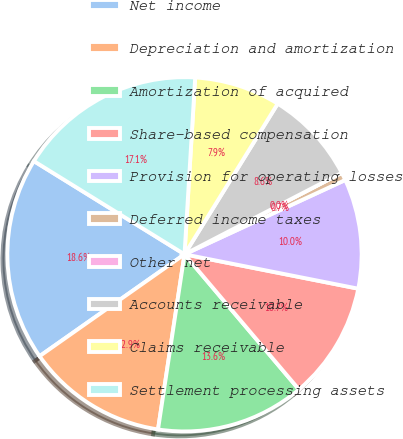<chart> <loc_0><loc_0><loc_500><loc_500><pie_chart><fcel>Net income<fcel>Depreciation and amortization<fcel>Amortization of acquired<fcel>Share-based compensation<fcel>Provision for operating losses<fcel>Deferred income taxes<fcel>Other net<fcel>Accounts receivable<fcel>Claims receivable<fcel>Settlement processing assets<nl><fcel>18.57%<fcel>12.86%<fcel>13.57%<fcel>10.71%<fcel>10.0%<fcel>0.72%<fcel>0.0%<fcel>8.57%<fcel>7.86%<fcel>17.14%<nl></chart> 